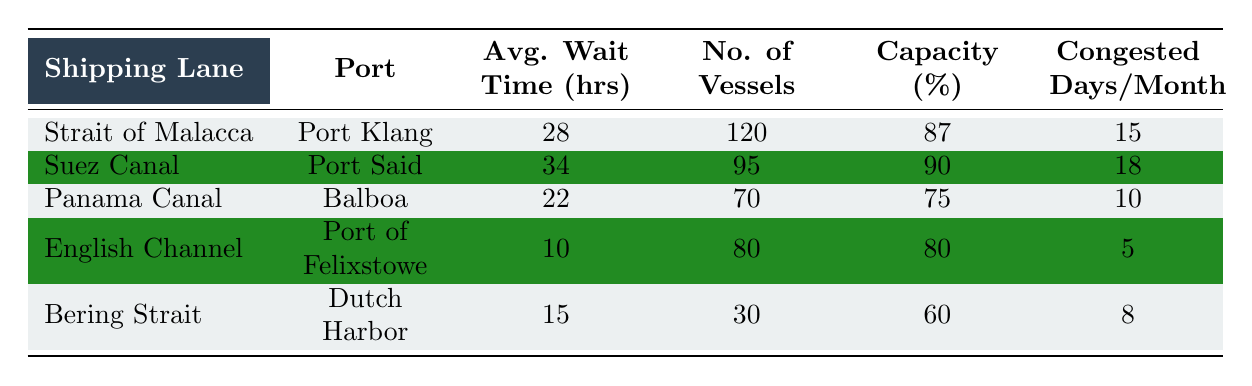What is the average wait time at Port Klang? From the table, the average wait time at Port Klang is directly listed in the corresponding row for the Strait of Malacca, which is 28 hours.
Answer: 28 hours Which shipping lane has the highest percentage capacity utilized? The percentage capacity for each shipping lane is provided in the table. The Suez Canal has 90%, which is the highest percentage compared to the other lanes.
Answer: Suez Canal What is the total number of vessels across all ports? To find the total number of vessels, sum the values in the "No. of Vessels" column: 120 + 95 + 70 + 80 + 30 = 395.
Answer: 395 Is the number of congested days per month at the Bering Strait less than 10? According to the table, the Bering Strait has 8 congested days per month, which is indeed less than 10.
Answer: Yes What is the average wait time across all ports? To calculate the average wait time, first sum the average wait times: 28 + 34 + 22 + 10 + 15 = 109. Then, divide by the number of ports, which is 5. Therefore, the average wait time is 109 / 5 = 21.8 hours.
Answer: 21.8 hours Which port has the lowest average wait time, and what is that time? From the table, the port with the lowest average wait time is the Port of Felixstowe, with an average wait time of 10 hours, as presented in the row for the English Channel.
Answer: Port of Felixstowe, 10 hours Are there more than 100 vessels at the Strait of Malacca? The table indicates that there are 120 vessels at the Strait of Malacca, which is indeed more than 100.
Answer: Yes Calculate the difference in average wait time between Port Klang and Port Said. The average wait time at Port Klang is 28 hours and at Port Said is 34 hours. The difference is 34 - 28 = 6 hours.
Answer: 6 hours How many shipping lanes have an average wait time over 25 hours? From the table, the lanes with average wait times over 25 hours are the Strait of Malacca (28), Suez Canal (34), and Port of Balboa (22). Therefore, there are 2 lanes with wait times over 25 hours.
Answer: 2 